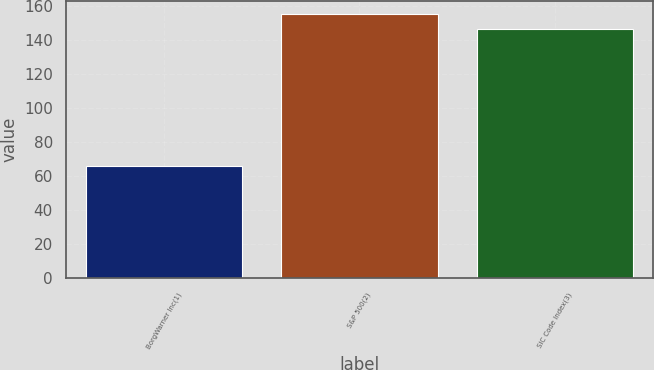Convert chart. <chart><loc_0><loc_0><loc_500><loc_500><bar_chart><fcel>BorgWarner Inc(1)<fcel>S&P 500(2)<fcel>SIC Code Index(3)<nl><fcel>66.14<fcel>155.07<fcel>146.65<nl></chart> 